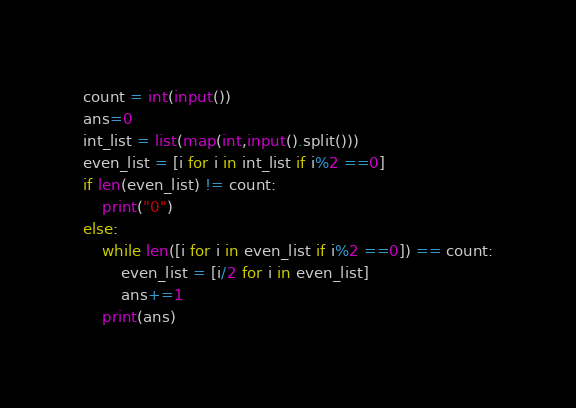<code> <loc_0><loc_0><loc_500><loc_500><_Python_>count = int(input())
ans=0
int_list = list(map(int,input().split()))
even_list = [i for i in int_list if i%2 ==0]
if len(even_list) != count:
    print("0")
else:
    while len([i for i in even_list if i%2 ==0]) == count:
        even_list = [i/2 for i in even_list]
        ans+=1
    print(ans)
</code> 